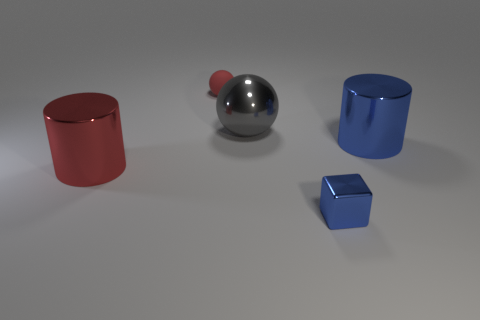Is the block the same color as the metal sphere?
Provide a short and direct response. No. There is a object that is the same color as the matte ball; what shape is it?
Your response must be concise. Cylinder. There is a shiny cylinder that is the same color as the block; what size is it?
Keep it short and to the point. Large. What shape is the shiny thing that is to the left of the tiny blue block and on the right side of the large red shiny cylinder?
Make the answer very short. Sphere. What number of other objects are there of the same shape as the big gray thing?
Your answer should be very brief. 1. What shape is the object in front of the metal cylinder that is in front of the big cylinder behind the large red cylinder?
Provide a succinct answer. Cube. What number of objects are either big spheres or red objects on the left side of the matte thing?
Give a very brief answer. 2. Does the metallic thing that is on the right side of the cube have the same shape as the small thing that is in front of the small rubber thing?
Provide a succinct answer. No. How many things are tiny cyan objects or blue blocks?
Your answer should be compact. 1. Is there any other thing that has the same material as the big blue thing?
Give a very brief answer. Yes. 